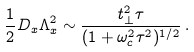<formula> <loc_0><loc_0><loc_500><loc_500>\frac { 1 } { 2 } D _ { x } \Lambda _ { x } ^ { 2 } \sim \frac { t _ { \perp } ^ { 2 } \tau } { ( 1 + \omega _ { c } ^ { 2 } \tau ^ { 2 } ) ^ { 1 / 2 } } \, .</formula> 